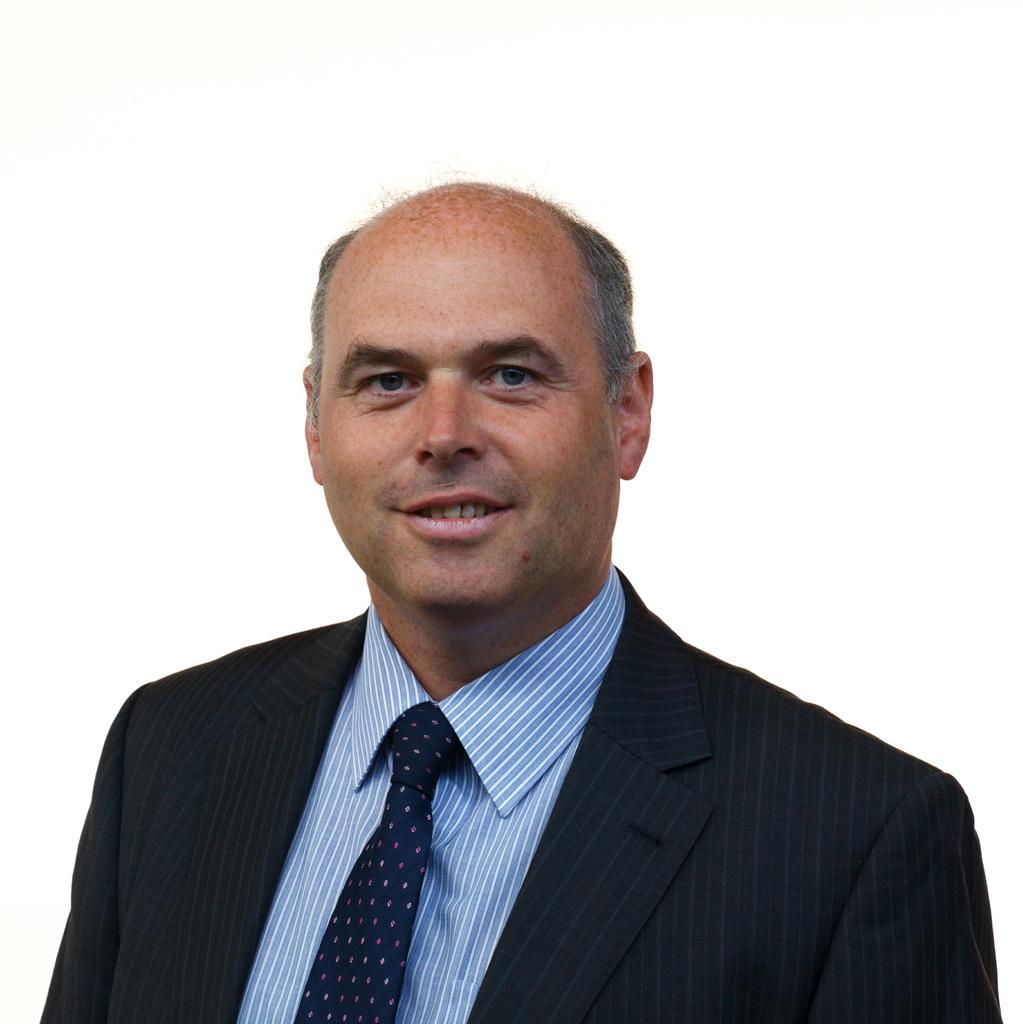Could you give a brief overview of what you see in this image? In this image there is a man with a smiling face. He is wearing a black suit, tie and blue shirt. 